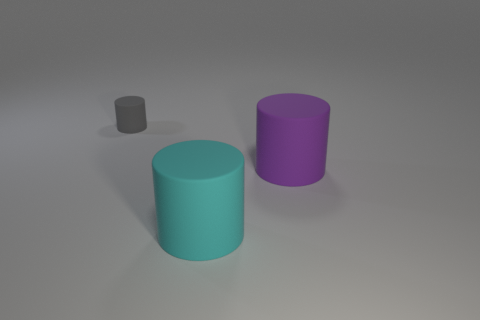Is the gray thing made of the same material as the big cyan cylinder?
Make the answer very short. Yes. How many things are left of the cyan matte cylinder?
Keep it short and to the point. 1. There is a object that is both behind the cyan rubber object and in front of the gray matte thing; what material is it made of?
Ensure brevity in your answer.  Rubber. How many purple rubber cylinders have the same size as the gray matte thing?
Provide a short and direct response. 0. There is a big object that is in front of the large rubber object on the right side of the big cyan matte object; what is its color?
Offer a terse response. Cyan. Are there any large blue metallic things?
Ensure brevity in your answer.  No. Does the large cyan rubber thing have the same shape as the large purple object?
Keep it short and to the point. Yes. There is a big matte cylinder to the left of the large purple thing; what number of cylinders are left of it?
Give a very brief answer. 1. What number of objects are both left of the large purple thing and behind the large cyan matte thing?
Provide a succinct answer. 1. What number of objects are either large purple matte cylinders or big objects that are in front of the big purple rubber cylinder?
Provide a succinct answer. 2. 